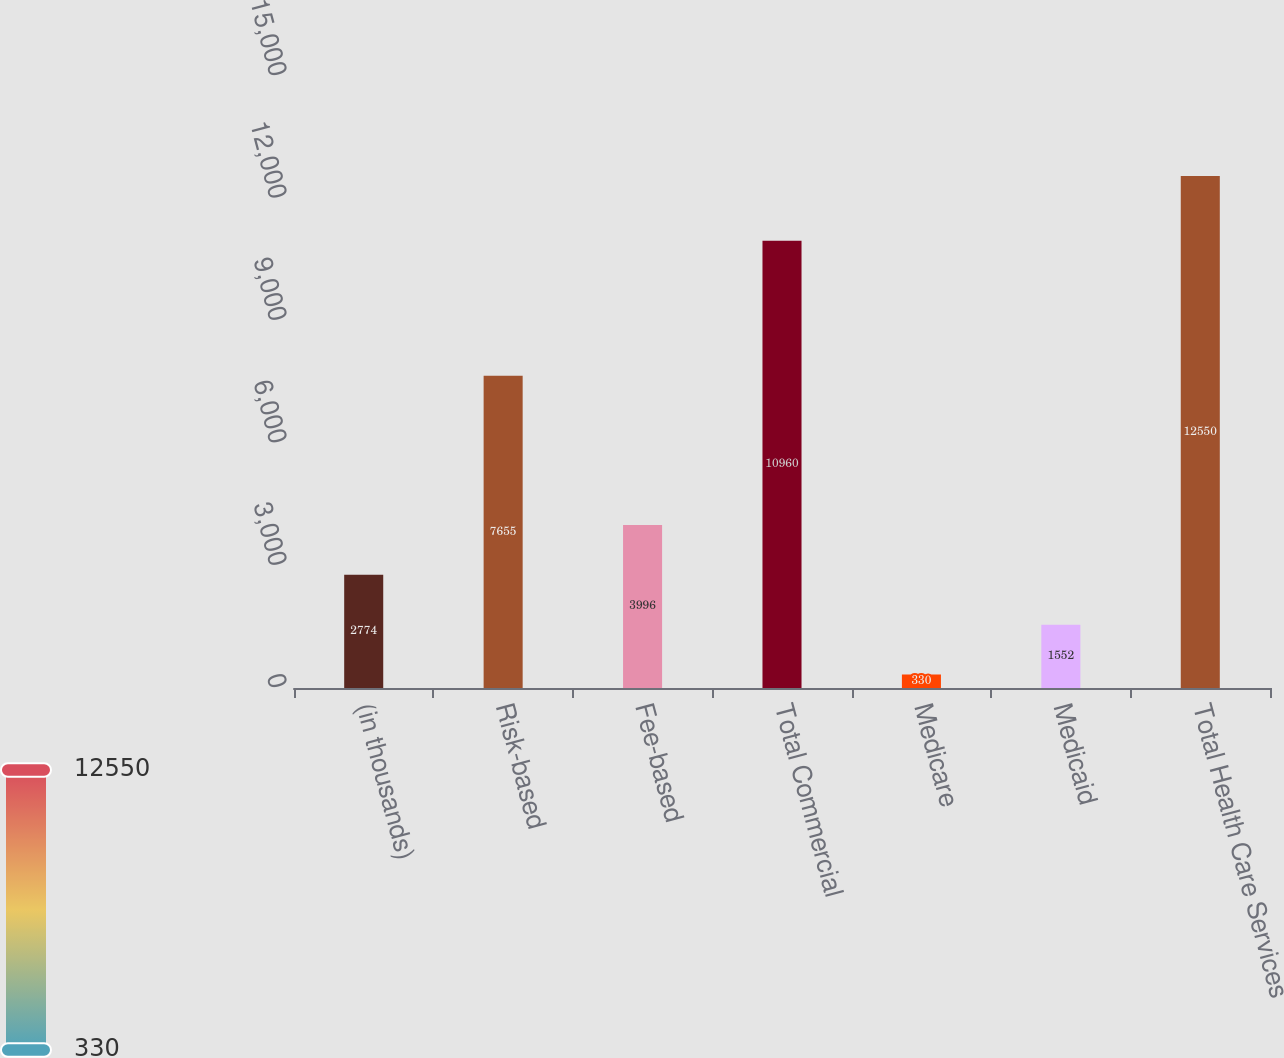Convert chart. <chart><loc_0><loc_0><loc_500><loc_500><bar_chart><fcel>(in thousands)<fcel>Risk-based<fcel>Fee-based<fcel>Total Commercial<fcel>Medicare<fcel>Medicaid<fcel>Total Health Care Services<nl><fcel>2774<fcel>7655<fcel>3996<fcel>10960<fcel>330<fcel>1552<fcel>12550<nl></chart> 